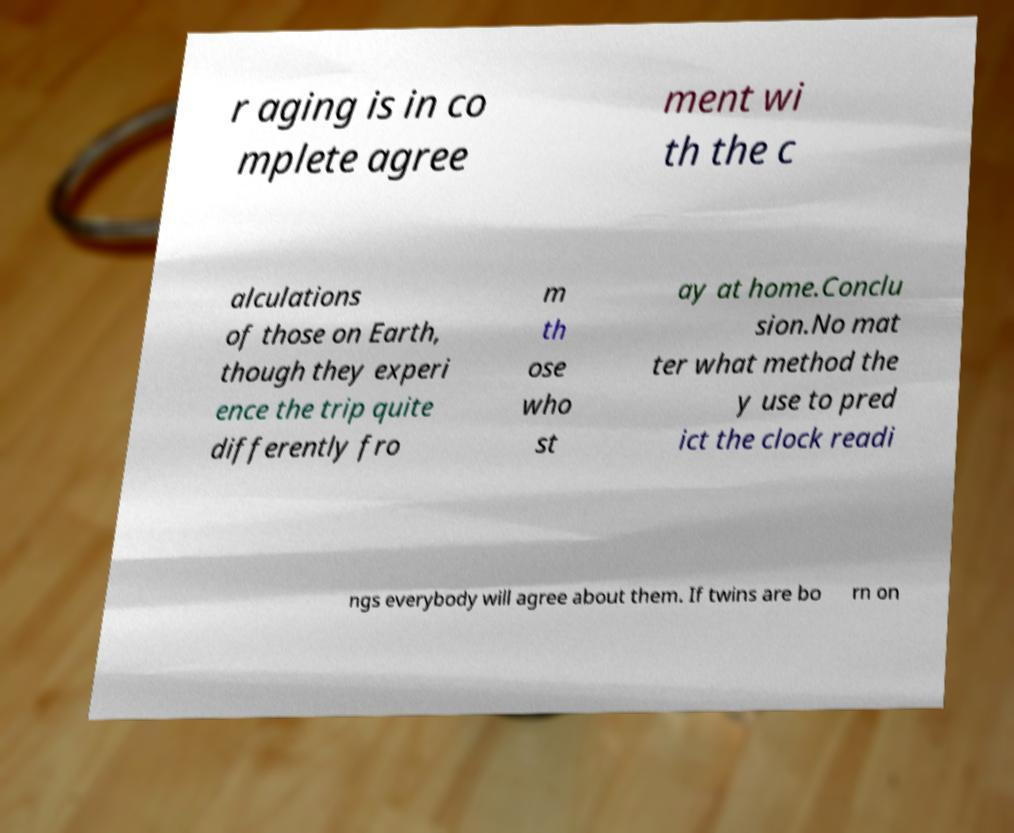Could you assist in decoding the text presented in this image and type it out clearly? r aging is in co mplete agree ment wi th the c alculations of those on Earth, though they experi ence the trip quite differently fro m th ose who st ay at home.Conclu sion.No mat ter what method the y use to pred ict the clock readi ngs everybody will agree about them. If twins are bo rn on 